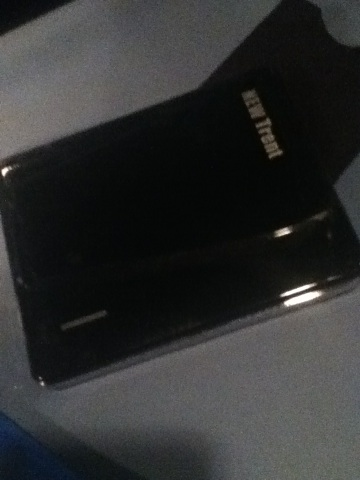What is this make and model? The image shows an object that appears to be an external hard drive. However, due to the image's blurred and dark nature, it is challenging to identify the exact make and model. The 'ATA/IDE' label visible on the object hints that it might be a computer peripheral, possibly a hard drive or an adapter. For more accurate identification, a clearer image or additional details might be required. 